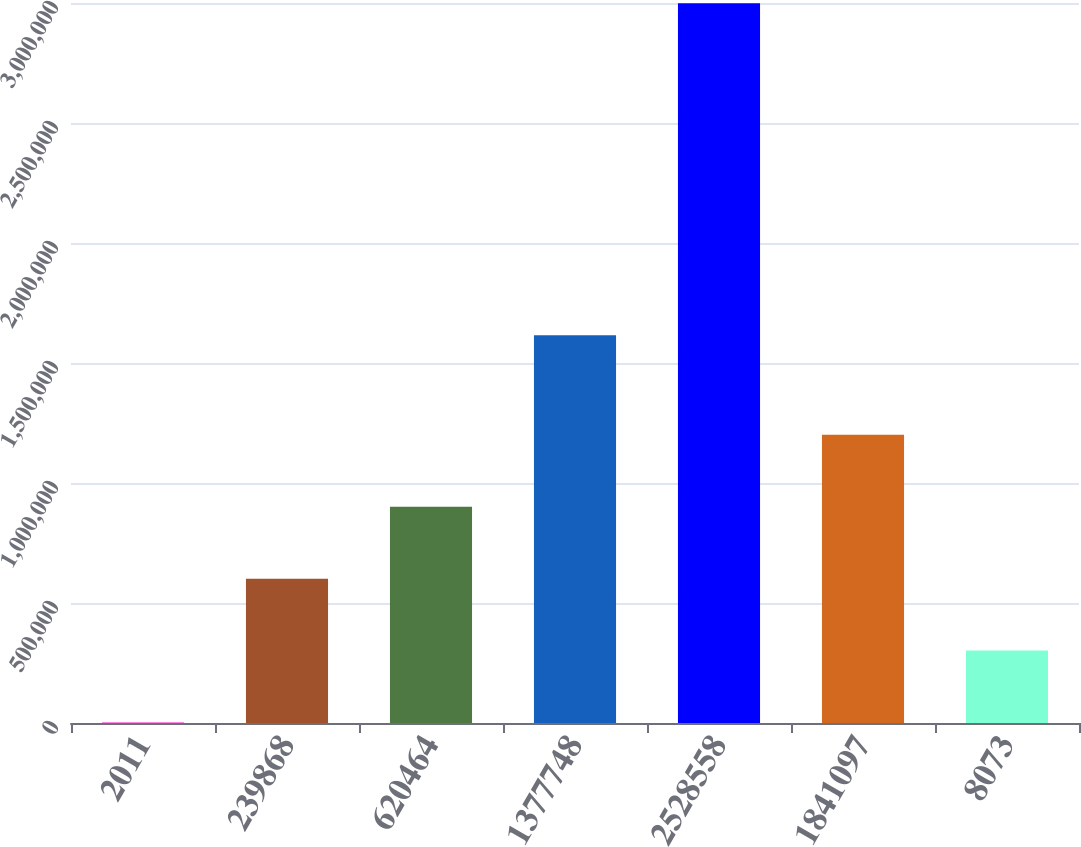<chart> <loc_0><loc_0><loc_500><loc_500><bar_chart><fcel>2011<fcel>239868<fcel>620464<fcel>1377748<fcel>2528558<fcel>1841097<fcel>8073<nl><fcel>2010<fcel>601422<fcel>901129<fcel>1.61574e+06<fcel>2.99907e+06<fcel>1.20083e+06<fcel>301716<nl></chart> 